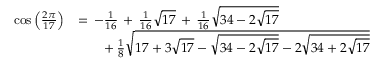Convert formula to latex. <formula><loc_0><loc_0><loc_500><loc_500>{ \begin{array} { r l } { \cos { \left ( { \frac { 2 \pi } { 1 7 } } \right ) } } & { = \, - { \frac { 1 } { 1 6 } } \, + \, { \frac { 1 } { 1 6 } } { \sqrt { 1 7 } } \, + \, { \frac { 1 } { 1 6 } } { \sqrt { 3 4 - 2 { \sqrt { 1 7 } } } } } \\ & { \quad + \, { \frac { 1 } { 8 } } { \sqrt { 1 7 + 3 { \sqrt { 1 7 } } - { \sqrt { 3 4 - 2 { \sqrt { 1 7 } } } } - 2 { \sqrt { 3 4 + 2 { \sqrt { 1 7 } } } } } } } \end{array} }</formula> 